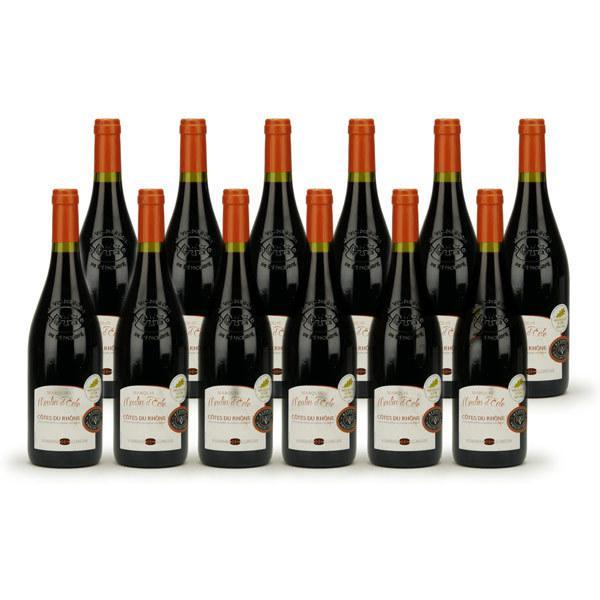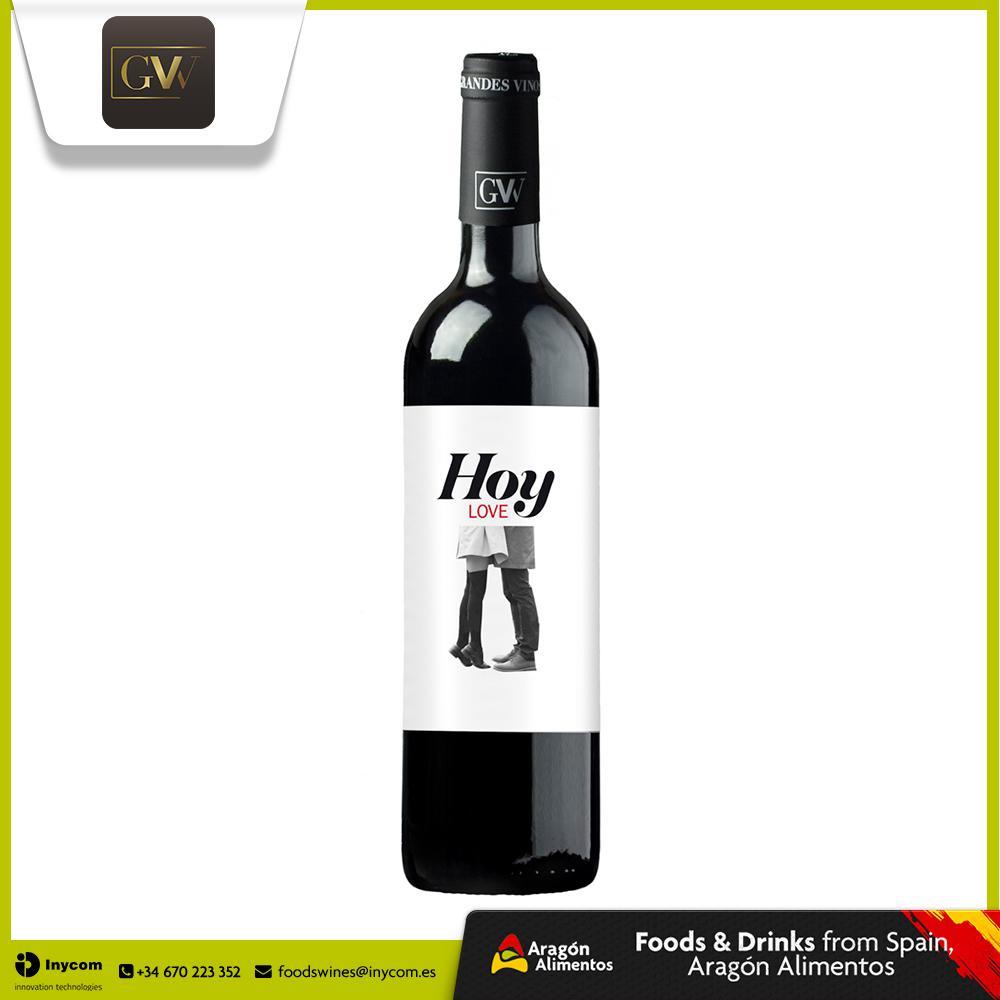The first image is the image on the left, the second image is the image on the right. Examine the images to the left and right. Is the description "There are no more than three wine bottles in the left image." accurate? Answer yes or no. No. The first image is the image on the left, the second image is the image on the right. Examine the images to the left and right. Is the description "Exactly six bottles of wine are capped and have labels, and are divided into two groups, at least two bottles in each group." accurate? Answer yes or no. No. 